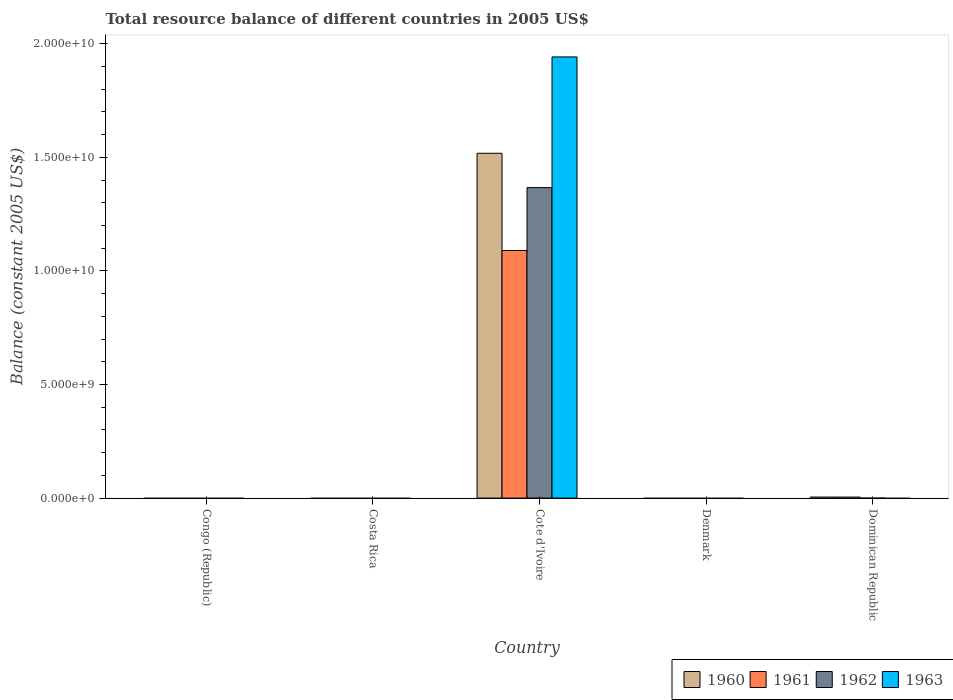Are the number of bars per tick equal to the number of legend labels?
Your answer should be very brief. No. Are the number of bars on each tick of the X-axis equal?
Your response must be concise. No. How many bars are there on the 1st tick from the left?
Provide a succinct answer. 0. How many bars are there on the 2nd tick from the right?
Provide a short and direct response. 0. What is the label of the 3rd group of bars from the left?
Keep it short and to the point. Cote d'Ivoire. Across all countries, what is the maximum total resource balance in 1960?
Make the answer very short. 1.52e+1. Across all countries, what is the minimum total resource balance in 1961?
Your answer should be very brief. 0. In which country was the total resource balance in 1962 maximum?
Make the answer very short. Cote d'Ivoire. What is the total total resource balance in 1962 in the graph?
Offer a very short reply. 1.37e+1. What is the difference between the total resource balance in 1962 in Congo (Republic) and the total resource balance in 1963 in Denmark?
Your answer should be compact. 0. What is the average total resource balance in 1961 per country?
Offer a very short reply. 2.19e+09. What is the difference between the total resource balance of/in 1960 and total resource balance of/in 1961 in Cote d'Ivoire?
Offer a terse response. 4.28e+09. In how many countries, is the total resource balance in 1962 greater than 15000000000 US$?
Provide a succinct answer. 0. What is the difference between the highest and the lowest total resource balance in 1961?
Give a very brief answer. 1.09e+1. In how many countries, is the total resource balance in 1960 greater than the average total resource balance in 1960 taken over all countries?
Keep it short and to the point. 1. Is it the case that in every country, the sum of the total resource balance in 1962 and total resource balance in 1963 is greater than the total resource balance in 1961?
Provide a succinct answer. No. Are the values on the major ticks of Y-axis written in scientific E-notation?
Give a very brief answer. Yes. Does the graph contain any zero values?
Offer a terse response. Yes. What is the title of the graph?
Provide a succinct answer. Total resource balance of different countries in 2005 US$. Does "2003" appear as one of the legend labels in the graph?
Give a very brief answer. No. What is the label or title of the X-axis?
Provide a short and direct response. Country. What is the label or title of the Y-axis?
Ensure brevity in your answer.  Balance (constant 2005 US$). What is the Balance (constant 2005 US$) in 1962 in Congo (Republic)?
Your response must be concise. 0. What is the Balance (constant 2005 US$) in 1963 in Congo (Republic)?
Offer a terse response. 0. What is the Balance (constant 2005 US$) in 1961 in Costa Rica?
Ensure brevity in your answer.  0. What is the Balance (constant 2005 US$) in 1963 in Costa Rica?
Offer a very short reply. 0. What is the Balance (constant 2005 US$) in 1960 in Cote d'Ivoire?
Provide a succinct answer. 1.52e+1. What is the Balance (constant 2005 US$) of 1961 in Cote d'Ivoire?
Give a very brief answer. 1.09e+1. What is the Balance (constant 2005 US$) in 1962 in Cote d'Ivoire?
Provide a short and direct response. 1.37e+1. What is the Balance (constant 2005 US$) of 1963 in Cote d'Ivoire?
Ensure brevity in your answer.  1.94e+1. What is the Balance (constant 2005 US$) of 1962 in Denmark?
Your answer should be compact. 0. What is the Balance (constant 2005 US$) of 1963 in Denmark?
Your answer should be very brief. 0. What is the Balance (constant 2005 US$) in 1960 in Dominican Republic?
Ensure brevity in your answer.  4.56e+07. What is the Balance (constant 2005 US$) in 1961 in Dominican Republic?
Provide a succinct answer. 4.52e+07. What is the Balance (constant 2005 US$) in 1962 in Dominican Republic?
Offer a very short reply. 0. What is the Balance (constant 2005 US$) in 1963 in Dominican Republic?
Your response must be concise. 0. Across all countries, what is the maximum Balance (constant 2005 US$) of 1960?
Offer a very short reply. 1.52e+1. Across all countries, what is the maximum Balance (constant 2005 US$) of 1961?
Keep it short and to the point. 1.09e+1. Across all countries, what is the maximum Balance (constant 2005 US$) in 1962?
Make the answer very short. 1.37e+1. Across all countries, what is the maximum Balance (constant 2005 US$) of 1963?
Provide a succinct answer. 1.94e+1. Across all countries, what is the minimum Balance (constant 2005 US$) in 1962?
Make the answer very short. 0. What is the total Balance (constant 2005 US$) of 1960 in the graph?
Ensure brevity in your answer.  1.52e+1. What is the total Balance (constant 2005 US$) in 1961 in the graph?
Provide a short and direct response. 1.09e+1. What is the total Balance (constant 2005 US$) of 1962 in the graph?
Make the answer very short. 1.37e+1. What is the total Balance (constant 2005 US$) in 1963 in the graph?
Give a very brief answer. 1.94e+1. What is the difference between the Balance (constant 2005 US$) of 1960 in Cote d'Ivoire and that in Dominican Republic?
Offer a very short reply. 1.51e+1. What is the difference between the Balance (constant 2005 US$) in 1961 in Cote d'Ivoire and that in Dominican Republic?
Your answer should be compact. 1.09e+1. What is the difference between the Balance (constant 2005 US$) of 1960 in Cote d'Ivoire and the Balance (constant 2005 US$) of 1961 in Dominican Republic?
Ensure brevity in your answer.  1.51e+1. What is the average Balance (constant 2005 US$) in 1960 per country?
Your answer should be compact. 3.05e+09. What is the average Balance (constant 2005 US$) of 1961 per country?
Your answer should be compact. 2.19e+09. What is the average Balance (constant 2005 US$) in 1962 per country?
Keep it short and to the point. 2.73e+09. What is the average Balance (constant 2005 US$) in 1963 per country?
Your answer should be very brief. 3.88e+09. What is the difference between the Balance (constant 2005 US$) in 1960 and Balance (constant 2005 US$) in 1961 in Cote d'Ivoire?
Your response must be concise. 4.28e+09. What is the difference between the Balance (constant 2005 US$) of 1960 and Balance (constant 2005 US$) of 1962 in Cote d'Ivoire?
Your answer should be compact. 1.51e+09. What is the difference between the Balance (constant 2005 US$) in 1960 and Balance (constant 2005 US$) in 1963 in Cote d'Ivoire?
Give a very brief answer. -4.24e+09. What is the difference between the Balance (constant 2005 US$) in 1961 and Balance (constant 2005 US$) in 1962 in Cote d'Ivoire?
Your answer should be very brief. -2.77e+09. What is the difference between the Balance (constant 2005 US$) in 1961 and Balance (constant 2005 US$) in 1963 in Cote d'Ivoire?
Your answer should be compact. -8.52e+09. What is the difference between the Balance (constant 2005 US$) of 1962 and Balance (constant 2005 US$) of 1963 in Cote d'Ivoire?
Provide a short and direct response. -5.75e+09. What is the ratio of the Balance (constant 2005 US$) of 1960 in Cote d'Ivoire to that in Dominican Republic?
Ensure brevity in your answer.  332.91. What is the ratio of the Balance (constant 2005 US$) in 1961 in Cote d'Ivoire to that in Dominican Republic?
Offer a very short reply. 241.17. What is the difference between the highest and the lowest Balance (constant 2005 US$) in 1960?
Make the answer very short. 1.52e+1. What is the difference between the highest and the lowest Balance (constant 2005 US$) in 1961?
Give a very brief answer. 1.09e+1. What is the difference between the highest and the lowest Balance (constant 2005 US$) of 1962?
Provide a succinct answer. 1.37e+1. What is the difference between the highest and the lowest Balance (constant 2005 US$) of 1963?
Keep it short and to the point. 1.94e+1. 